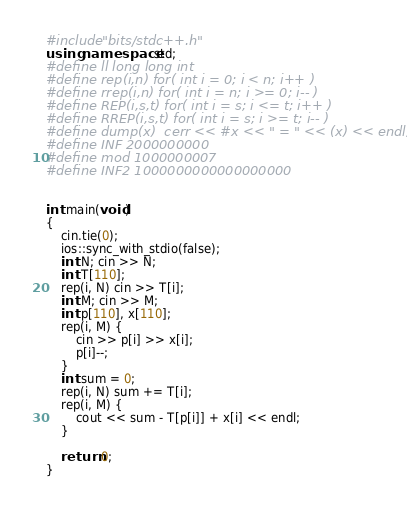Convert code to text. <code><loc_0><loc_0><loc_500><loc_500><_C++_>#include "bits/stdc++.h"
using namespace std;
#define ll long long int
#define rep(i,n) for( int i = 0; i < n; i++ )
#define rrep(i,n) for( int i = n; i >= 0; i-- )
#define REP(i,s,t) for( int i = s; i <= t; i++ )
#define RREP(i,s,t) for( int i = s; i >= t; i-- )
#define dump(x)  cerr << #x << " = " << (x) << endl;
#define INF 2000000000
#define mod 1000000007
#define INF2 1000000000000000000


int main(void)
{
    cin.tie(0);
    ios::sync_with_stdio(false);
    int N; cin >> N;
    int T[110];
    rep(i, N) cin >> T[i];
    int M; cin >> M;
    int p[110], x[110];
    rep(i, M) {
        cin >> p[i] >> x[i];
        p[i]--;
    }
    int sum = 0;
    rep(i, N) sum += T[i];
    rep(i, M) {
        cout << sum - T[p[i]] + x[i] << endl;
    }

    return 0;
}
</code> 